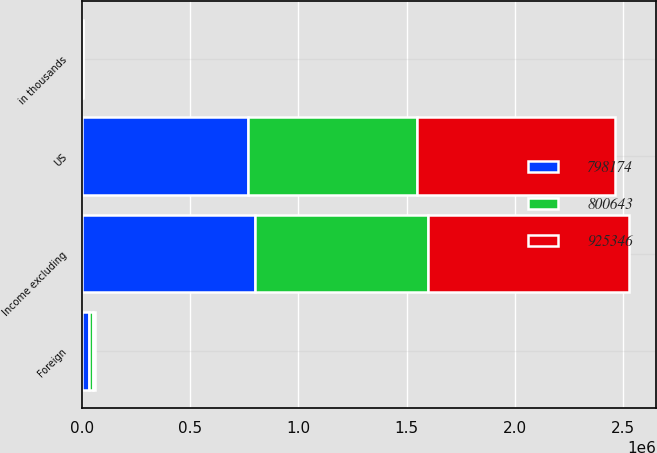Convert chart to OTSL. <chart><loc_0><loc_0><loc_500><loc_500><stacked_bar_chart><ecel><fcel>in thousands<fcel>US<fcel>Foreign<fcel>Income excluding<nl><fcel>925346<fcel>2017<fcel>915711<fcel>9635<fcel>925346<nl><fcel>798174<fcel>2016<fcel>765421<fcel>35222<fcel>800643<nl><fcel>800643<fcel>2015<fcel>782146<fcel>16028<fcel>798174<nl></chart> 